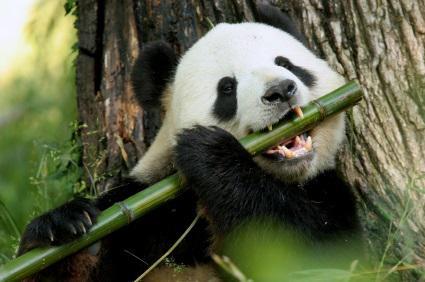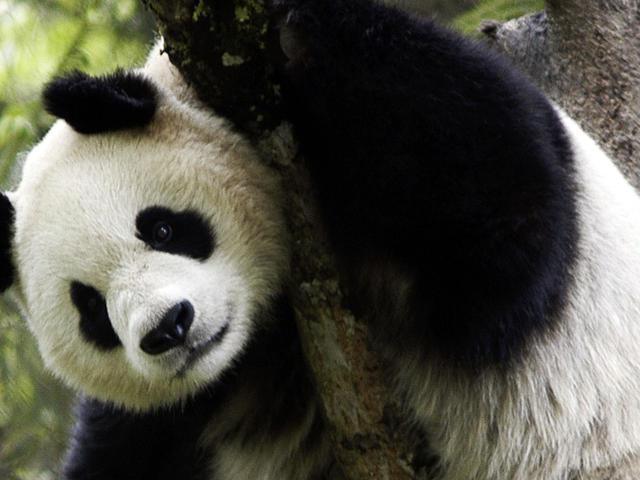The first image is the image on the left, the second image is the image on the right. Evaluate the accuracy of this statement regarding the images: "An image shows one open-mouthed panda clutching a leafless stalk.". Is it true? Answer yes or no. Yes. 